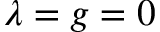<formula> <loc_0><loc_0><loc_500><loc_500>\lambda = g = 0</formula> 